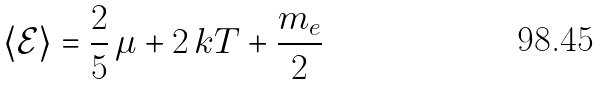<formula> <loc_0><loc_0><loc_500><loc_500>\langle \mathcal { E } \rangle = \frac { 2 } { 5 } \, \mu + 2 \, k T + \frac { m _ { e } } { 2 }</formula> 